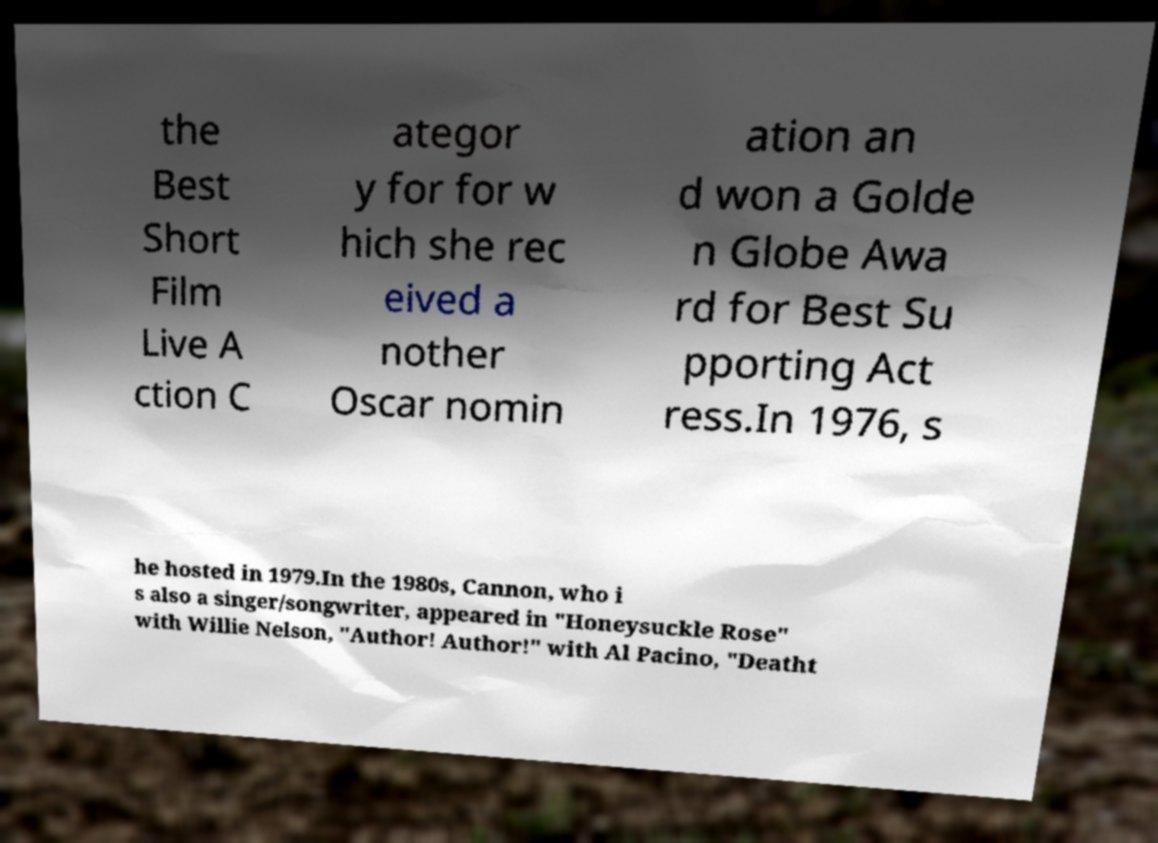I need the written content from this picture converted into text. Can you do that? the Best Short Film Live A ction C ategor y for for w hich she rec eived a nother Oscar nomin ation an d won a Golde n Globe Awa rd for Best Su pporting Act ress.In 1976, s he hosted in 1979.In the 1980s, Cannon, who i s also a singer/songwriter, appeared in "Honeysuckle Rose" with Willie Nelson, "Author! Author!" with Al Pacino, "Deatht 